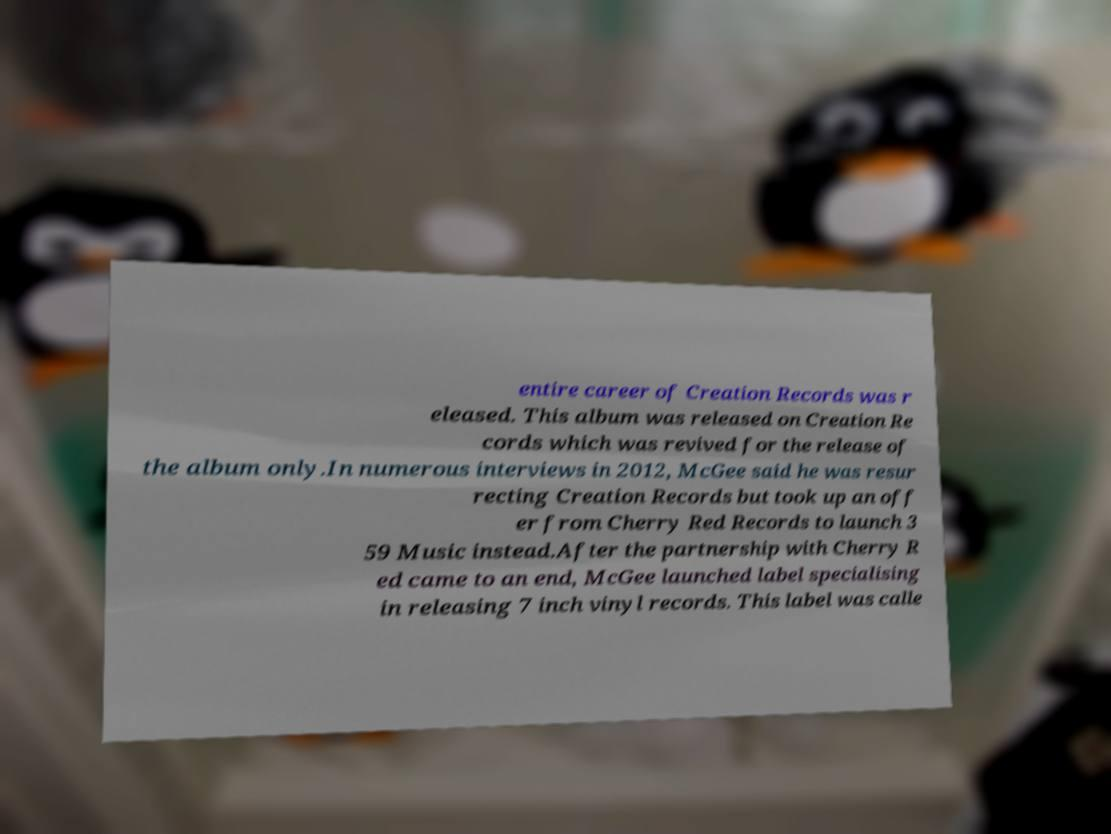Please read and relay the text visible in this image. What does it say? entire career of Creation Records was r eleased. This album was released on Creation Re cords which was revived for the release of the album only.In numerous interviews in 2012, McGee said he was resur recting Creation Records but took up an off er from Cherry Red Records to launch 3 59 Music instead.After the partnership with Cherry R ed came to an end, McGee launched label specialising in releasing 7 inch vinyl records. This label was calle 